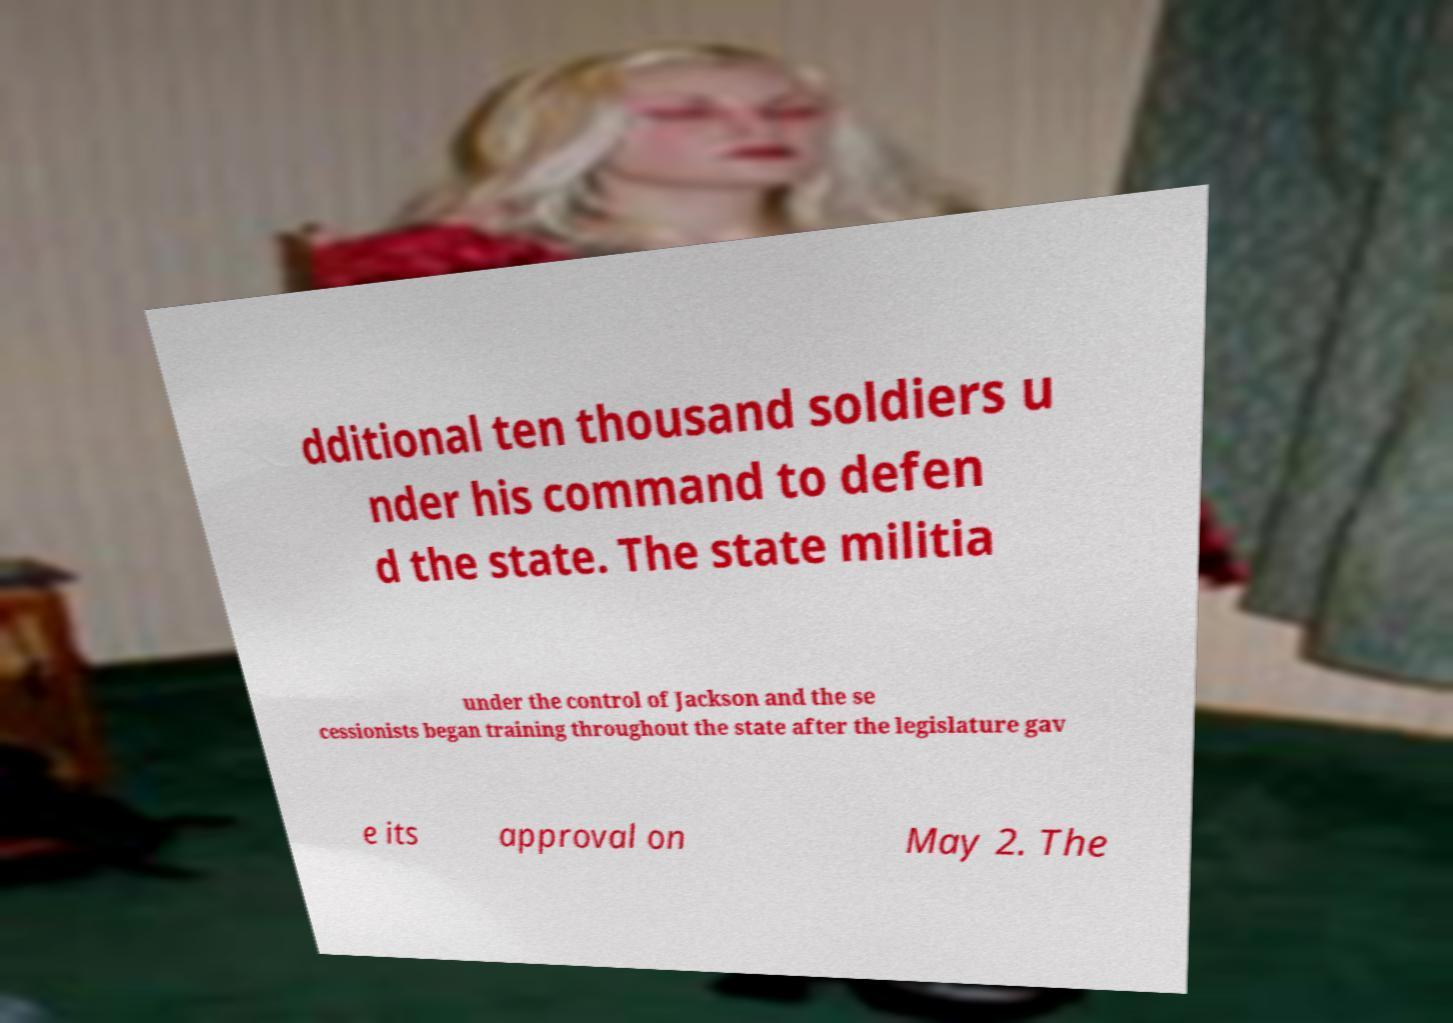Can you accurately transcribe the text from the provided image for me? dditional ten thousand soldiers u nder his command to defen d the state. The state militia under the control of Jackson and the se cessionists began training throughout the state after the legislature gav e its approval on May 2. The 